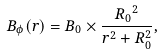<formula> <loc_0><loc_0><loc_500><loc_500>B _ { \phi } ( r ) = B _ { 0 } \times \frac { { R _ { 0 } } ^ { 2 } } { r ^ { 2 } + R _ { 0 } ^ { 2 } } ,</formula> 